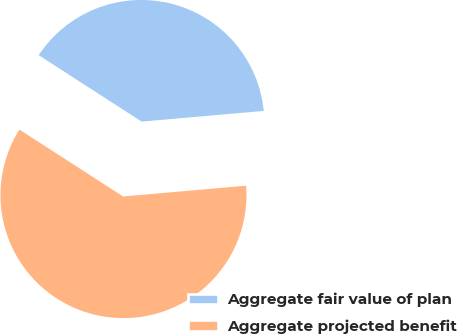<chart> <loc_0><loc_0><loc_500><loc_500><pie_chart><fcel>Aggregate fair value of plan<fcel>Aggregate projected benefit<nl><fcel>39.49%<fcel>60.51%<nl></chart> 